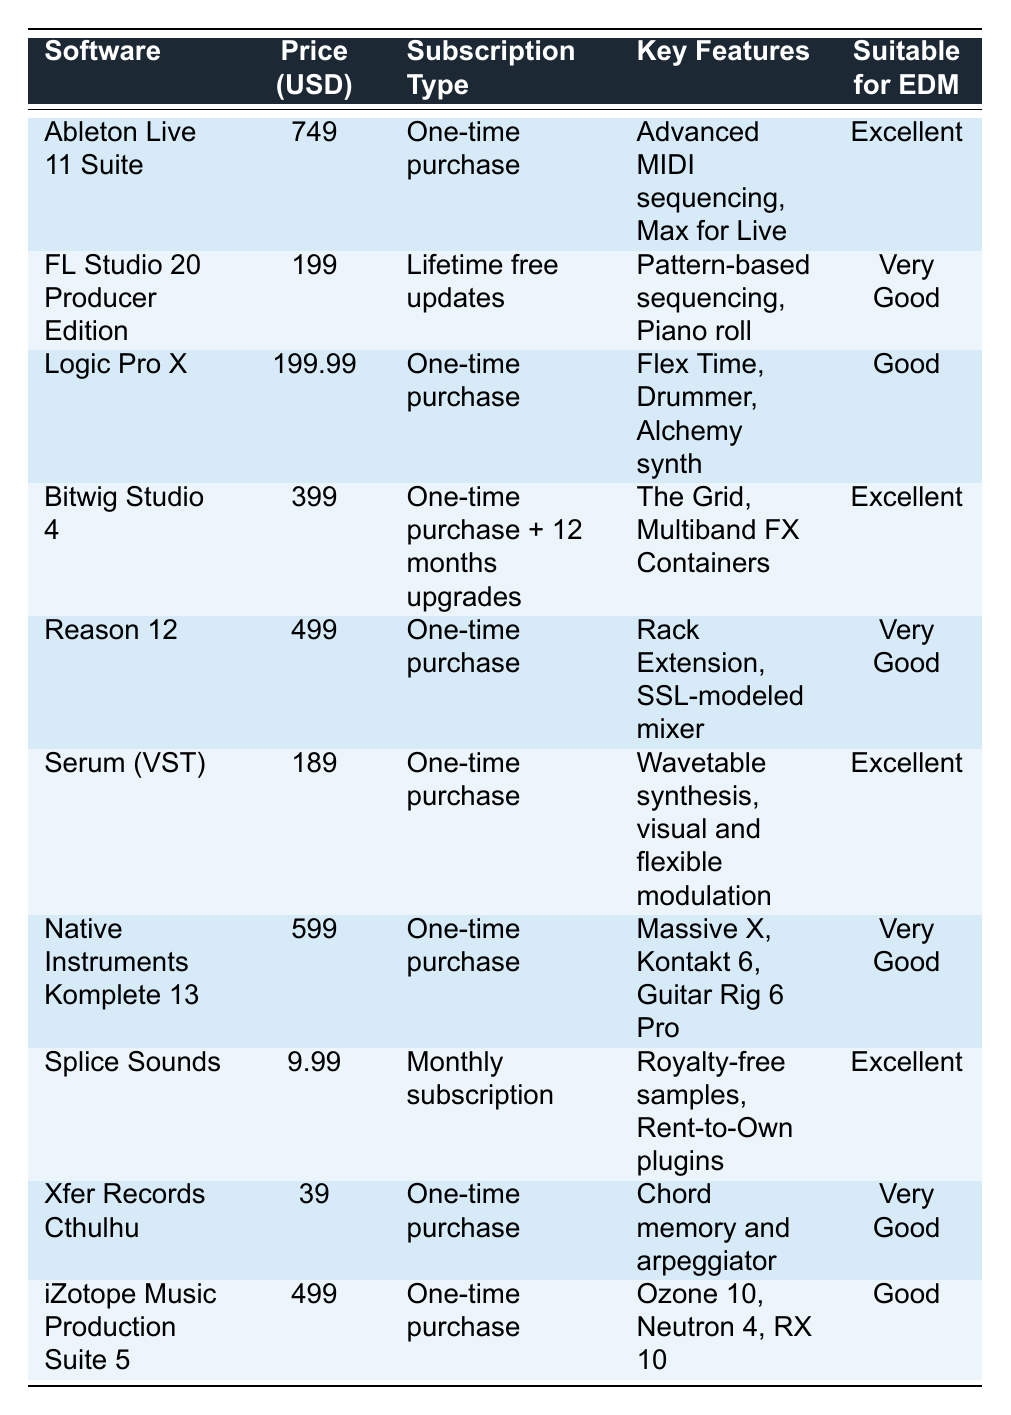What is the price of Ableton Live 11 Suite? The table lists the price of Ableton Live 11 Suite as 749 USD.
Answer: 749 USD Which software has the highest price? By reviewing the prices in the table, Ableton Live 11 Suite at 749 USD is the highest among the listed software.
Answer: Ableton Live 11 Suite Is Serum suitable for EDM production? The table indicates that Serum (VST) is marked as "Excellent" for suitability in EDM production.
Answer: Yes How many software options are there that offer a one-time purchase? Upon counting the entries in the table, there are 6 software options that offer a one-time purchase.
Answer: 6 What is the price difference between Logic Pro X and FL Studio 20 Producer Edition? The price of Logic Pro X is 199.99 USD and FL Studio 20 Producer Edition is 199 USD. The difference is 0.99 USD (199.99 - 199).
Answer: 0.99 USD What is the total price of all the software that has a one-time purchase pricing model? The software with a one-time purchase pricing is: Ableton Live 11 Suite (749), Logic Pro X (199.99), Bitwig Studio 4 (399), Reason 12 (499), Serum (189), Native Instruments Komplete 13 (599), and iZotope Music Production Suite 5 (499). The total is 749 + 199.99 + 399 + 499 + 189 + 599 + 499 = 3133.99 USD.
Answer: 3133.99 USD Is Splice Sounds more expensive than Xfer Records Cthulhu? According to the table, Splice Sounds costs 9.99 USD, while Xfer Records Cthulhu is priced at 39 USD. Hence, Splice Sounds is less expensive than Xfer Records Cthulhu.
Answer: No What percentage of the software listed are suitable for EDM? There are 8 software options listed as suitable for EDM or having a suitable rating. With a total of 10 software options, the percentage is (8/10) * 100 = 80%.
Answer: 80% Which software offers the lowest monthly subscription cost? The table shows that Splice Sounds has a monthly subscription cost of 9.99 USD, making it the lowest among subscription-based software.
Answer: Splice Sounds If I wanted to purchase Bitwig Studio 4 and Serum (VST), how much would I spend in total? The price of Bitwig Studio 4 is 399 USD and Serum (VST) is 189 USD. Adding these two amounts gives 399 + 189 = 588 USD.
Answer: 588 USD 